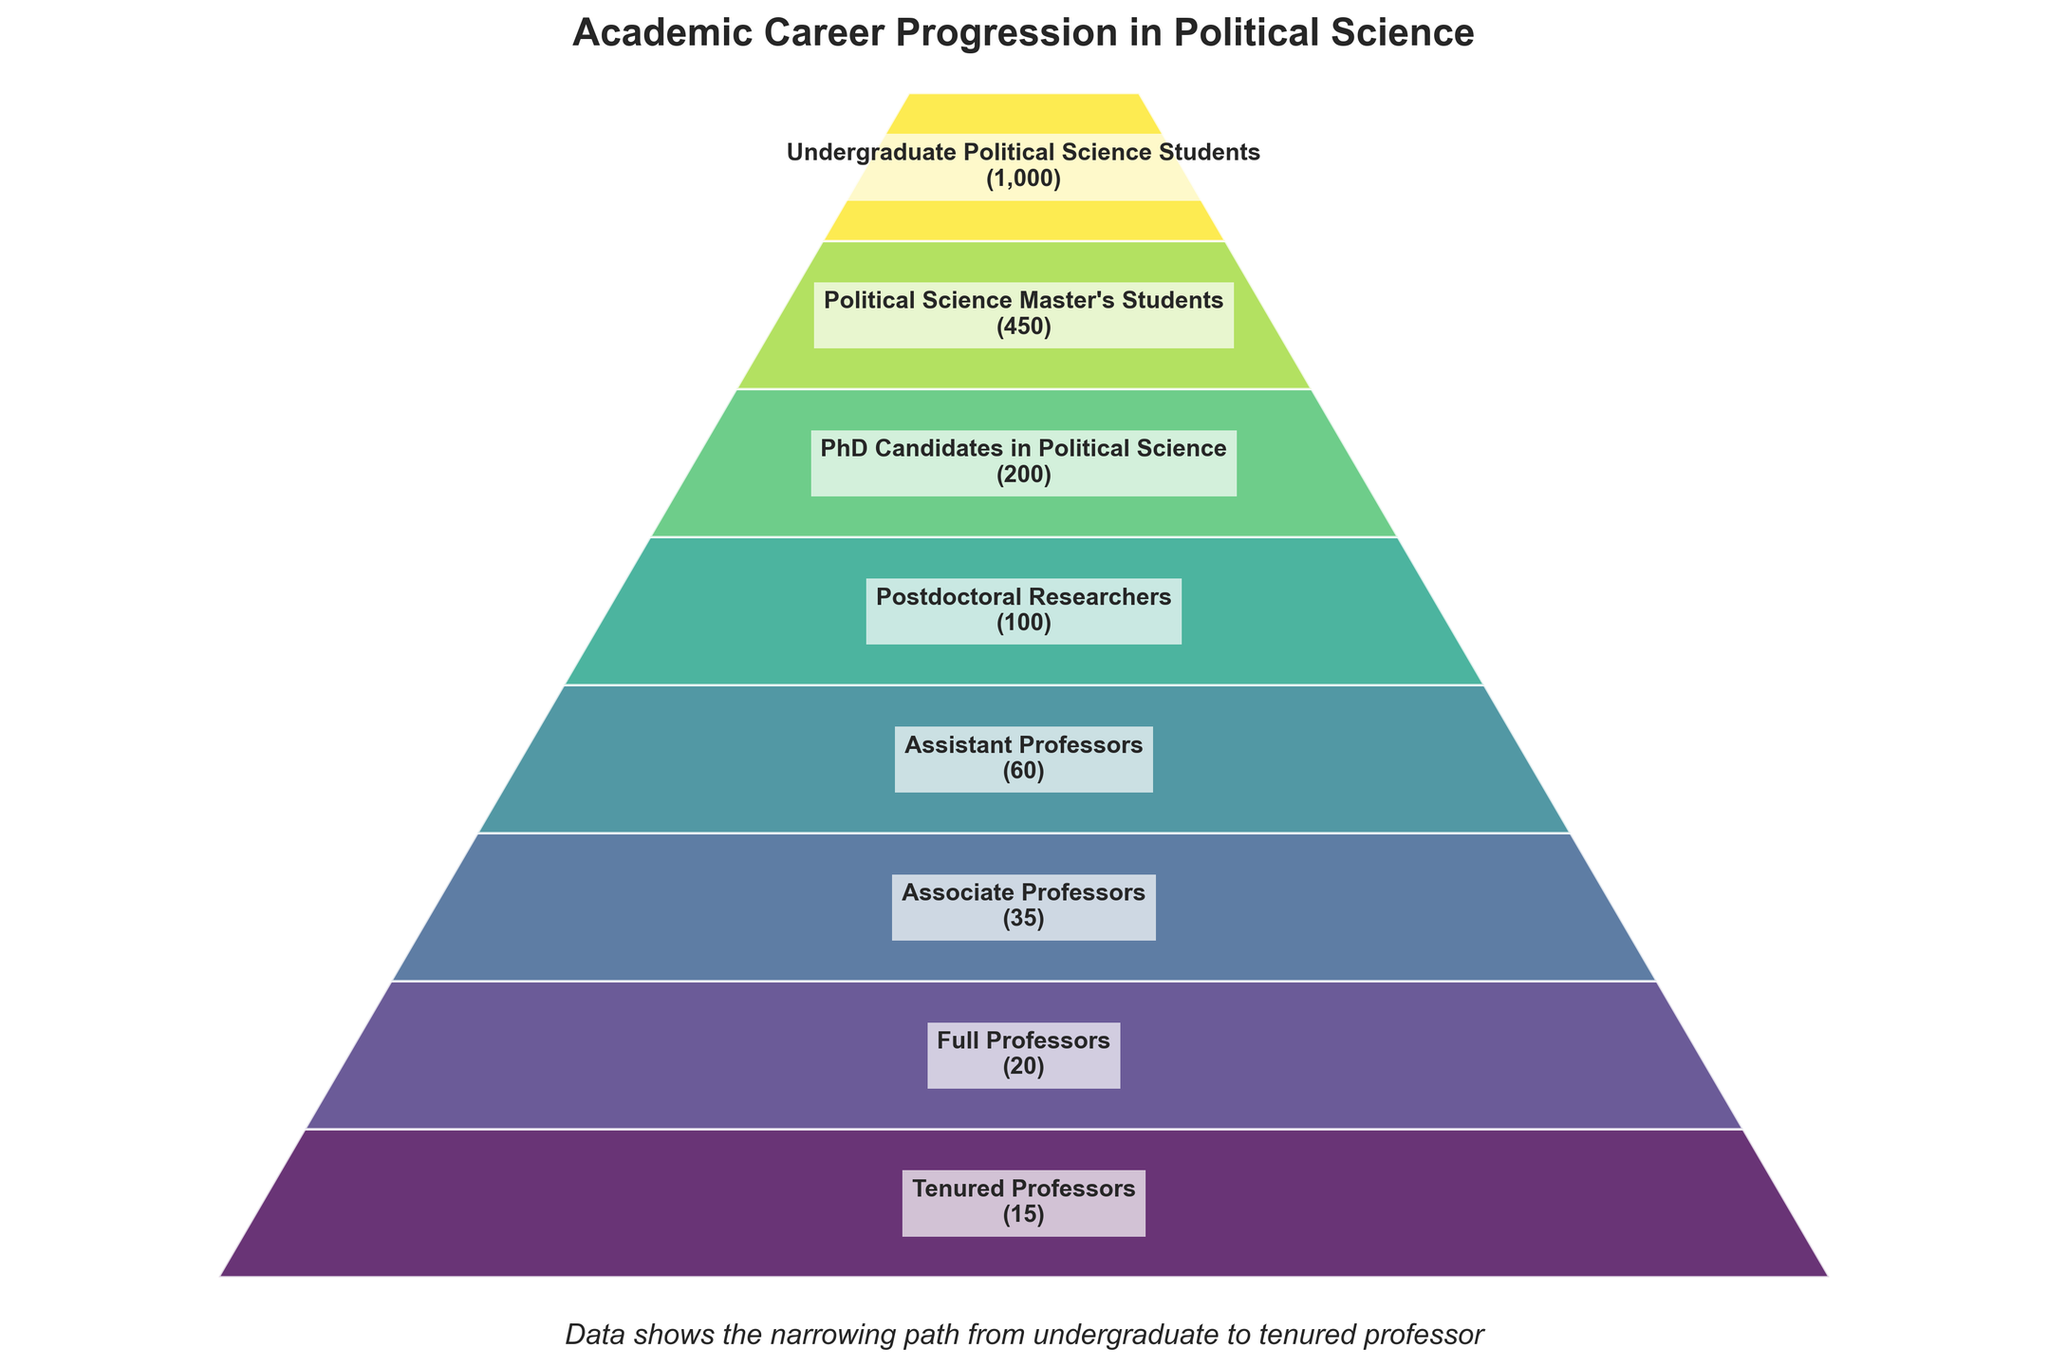What's the title of the figure? The title of the figure is prominently displayed at the top of the chart. It reads "Academic Career Progression in Political Science".
Answer: Academic Career Progression in Political Science How many stages are presented in the funnel chart? By counting the number of distinct stages labeled in the funnel, we can see there are 8 different stages presented.
Answer: 8 What is the number of undergraduate political science students compared to tenured professors? The number of undergraduate political science students is 1000, while the number of tenured professors is 15. These numbers can be read directly from the labels within the funnel chart.
Answer: 1000 and 15 By how much does the number decrease from undergraduate students to master's students? The number of undergraduate political science students is 1000, and the number of master's students is 450. The decrease is calculated by subtracting 450 from 1000.
Answer: 550 Which stage has the highest number of individuals, and which stage has the lowest? By inspecting the numerical values at each stage, the highest number is seen at "Undergraduate Political Science Students" with 1000 individuals, and the lowest at "Tenured Professors" with 15 individuals.
Answer: Undergraduate Political Science Students and Tenured Professors Which stages have less than 50 individuals? The number of individuals at each stage is labeled within the chart. The stages with less than 50 individuals are "Associate Professors" with 35, "Full Professors" with 20, and "Tenured Professors" with 15.
Answer: Associate Professors, Full Professors, and Tenured Professors What percentage of undergraduate students continue to master's level in political science? The number of master's students is 450 out of 1000 undergraduate students. The percentage calculation is (450 / 1000) * 100.
Answer: 45% How does the number of PhD candidates compare to the number of postdoctoral researchers? The figure indicates 200 PhD candidates and 100 postdoctoral researchers. The number of PhD candidates is twice the number of postdoctoral researchers.
Answer: PhD candidates are twice as many as postdoctoral researchers What is the total number of assistant, associate, full, and tenured professors? By adding the number of individuals at each stage: 60 (Assistant Professors) + 35 (Associate Professors) + 20 (Full Professors) + 15 (Tenured Professors), we get the total.
Answer: 130 What is the observed pattern in the width of the stages within the funnel chart? The width of each stage decreases as the number of individuals decreases, indicating the progressively narrowing path from undergraduate students to tenured professors.
Answer: The width decreases as the stages progress 